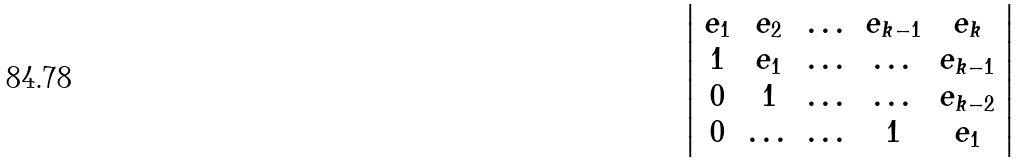Convert formula to latex. <formula><loc_0><loc_0><loc_500><loc_500>\left | \begin{array} { c c c c c } e _ { 1 } & e _ { 2 } & \dots & e _ { k - 1 } & e _ { k } \\ 1 & e _ { 1 } & \dots & \dots & e _ { k - 1 } \\ 0 & 1 & \dots & \dots & e _ { k - 2 } \\ 0 & \dots & \dots & 1 & e _ { 1 } \end{array} \right |</formula> 